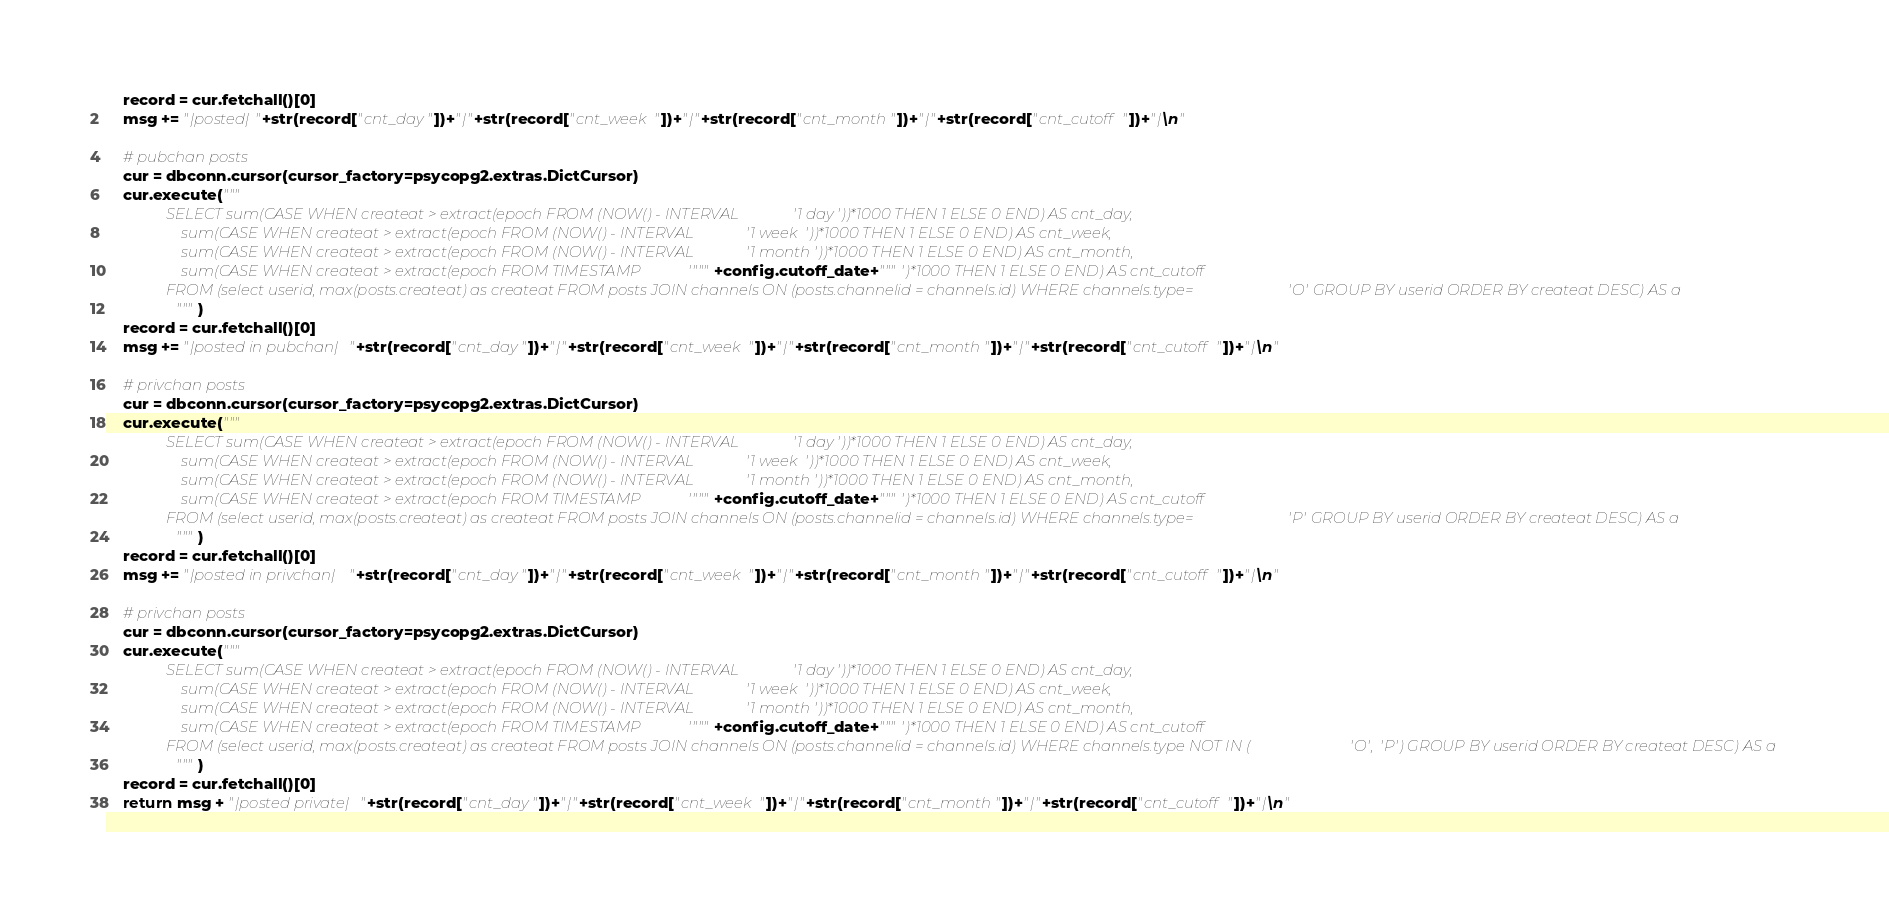Convert code to text. <code><loc_0><loc_0><loc_500><loc_500><_Python_>    record = cur.fetchall()[0]
    msg += "|posted|"+str(record["cnt_day"])+"|"+str(record["cnt_week"])+"|"+str(record["cnt_month"])+"|"+str(record["cnt_cutoff"])+"|\n"

    # pubchan posts
    cur = dbconn.cursor(cursor_factory=psycopg2.extras.DictCursor)
    cur.execute("""
                SELECT sum(CASE WHEN createat > extract(epoch FROM (NOW() - INTERVAL '1 day'))*1000 THEN 1 ELSE 0 END) AS cnt_day,
                    sum(CASE WHEN createat > extract(epoch FROM (NOW() - INTERVAL '1 week'))*1000 THEN 1 ELSE 0 END) AS cnt_week,
                    sum(CASE WHEN createat > extract(epoch FROM (NOW() - INTERVAL '1 month'))*1000 THEN 1 ELSE 0 END) AS cnt_month,
                    sum(CASE WHEN createat > extract(epoch FROM TIMESTAMP '"""+config.cutoff_date+"""')*1000 THEN 1 ELSE 0 END) AS cnt_cutoff
                FROM (select userid, max(posts.createat) as createat FROM posts JOIN channels ON (posts.channelid = channels.id) WHERE channels.type='O' GROUP BY userid ORDER BY createat DESC) AS a
                """)
    record = cur.fetchall()[0]
    msg += "|posted in pubchan|"+str(record["cnt_day"])+"|"+str(record["cnt_week"])+"|"+str(record["cnt_month"])+"|"+str(record["cnt_cutoff"])+"|\n"

    # privchan posts
    cur = dbconn.cursor(cursor_factory=psycopg2.extras.DictCursor)
    cur.execute("""
                SELECT sum(CASE WHEN createat > extract(epoch FROM (NOW() - INTERVAL '1 day'))*1000 THEN 1 ELSE 0 END) AS cnt_day,
                    sum(CASE WHEN createat > extract(epoch FROM (NOW() - INTERVAL '1 week'))*1000 THEN 1 ELSE 0 END) AS cnt_week,
                    sum(CASE WHEN createat > extract(epoch FROM (NOW() - INTERVAL '1 month'))*1000 THEN 1 ELSE 0 END) AS cnt_month,
                    sum(CASE WHEN createat > extract(epoch FROM TIMESTAMP '"""+config.cutoff_date+"""')*1000 THEN 1 ELSE 0 END) AS cnt_cutoff
                FROM (select userid, max(posts.createat) as createat FROM posts JOIN channels ON (posts.channelid = channels.id) WHERE channels.type='P' GROUP BY userid ORDER BY createat DESC) AS a
                """)
    record = cur.fetchall()[0]
    msg += "|posted in privchan|"+str(record["cnt_day"])+"|"+str(record["cnt_week"])+"|"+str(record["cnt_month"])+"|"+str(record["cnt_cutoff"])+"|\n"

    # privchan posts
    cur = dbconn.cursor(cursor_factory=psycopg2.extras.DictCursor)
    cur.execute("""
                SELECT sum(CASE WHEN createat > extract(epoch FROM (NOW() - INTERVAL '1 day'))*1000 THEN 1 ELSE 0 END) AS cnt_day,
                    sum(CASE WHEN createat > extract(epoch FROM (NOW() - INTERVAL '1 week'))*1000 THEN 1 ELSE 0 END) AS cnt_week,
                    sum(CASE WHEN createat > extract(epoch FROM (NOW() - INTERVAL '1 month'))*1000 THEN 1 ELSE 0 END) AS cnt_month,
                    sum(CASE WHEN createat > extract(epoch FROM TIMESTAMP '"""+config.cutoff_date+"""')*1000 THEN 1 ELSE 0 END) AS cnt_cutoff
                FROM (select userid, max(posts.createat) as createat FROM posts JOIN channels ON (posts.channelid = channels.id) WHERE channels.type NOT IN ('O', 'P') GROUP BY userid ORDER BY createat DESC) AS a
                """)
    record = cur.fetchall()[0]
    return msg + "|posted private|"+str(record["cnt_day"])+"|"+str(record["cnt_week"])+"|"+str(record["cnt_month"])+"|"+str(record["cnt_cutoff"])+"|\n"
</code> 